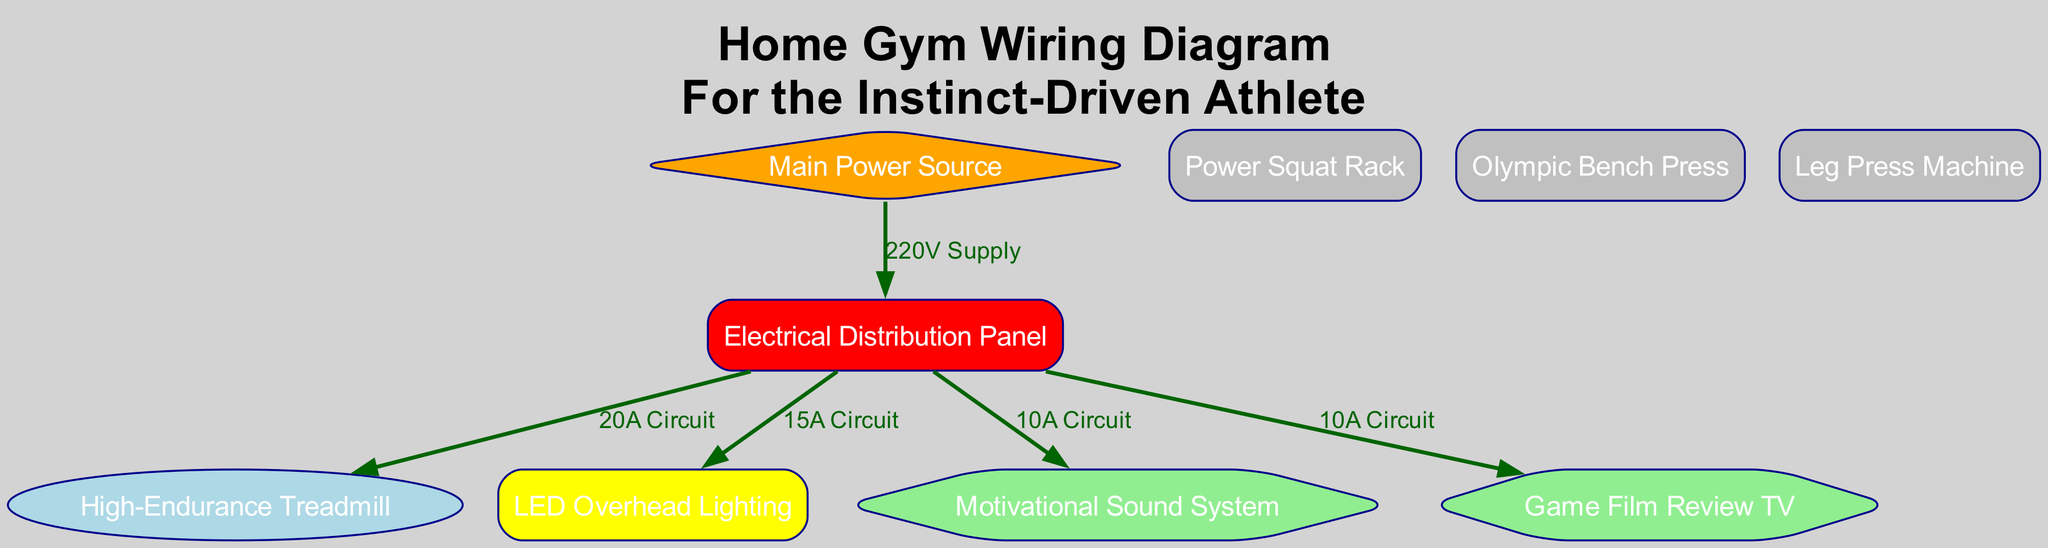What is the first node in the diagram? The first node in the diagram is labeled "Main Power Source". It is the starting point of the wiring configuration as it supplies power to other components.
Answer: Main Power Source How many total nodes are in the diagram? The diagram contains a total of eight nodes. This includes all the exercise equipment, power source, distribution panel, and additional features like lighting and sound system.
Answer: 8 What type of circuit powers the treadmill? The treadmill is powered by a "20A Circuit" that comes from the electrical distribution panel, specifically dedicated to the treadmill for high endurance usage.
Answer: 20A Circuit Which node is powered by the 15A Circuit? The "LED Overhead Lighting" node is powered by the 15A Circuit, indicating that this circuit supplies the necessary electrical requirements for the lighting system.
Answer: LED Overhead Lighting What is the relationship between the power source and the distribution panel? The relationship between the power source and distribution panel is characterized by the "220V Supply" that connects them, which provides the required voltage to operate various circuits in the gym setup.
Answer: 220V Supply How many connections are there exiting from the distribution panel? There are four connections exiting from the distribution panel. These connections lead to the treadmill, lighting, sound system, and TV, representing the circuits designated for those components.
Answer: 4 Is the Game Film Review TV connected to the power source directly? No, the Game Film Review TV is not connected directly to the power source; it is connected through the electrical distribution panel via a 10A Circuit. This signifies the need for proper electrical management in the gym setup.
Answer: No What color represents the lighting node in the diagram? The lighting node is represented in yellow, as shown in the diagram where color coding helps to differentiate among various types of equipment and features.
Answer: Yellow Which component has a higher amperage circuit, the sound system or the treadmill? The treadmill has a higher amperage circuit, at 20A, compared to the sound system which is powered by a 10A circuit, indicating a greater electrical demand for operation.
Answer: Treadmill 